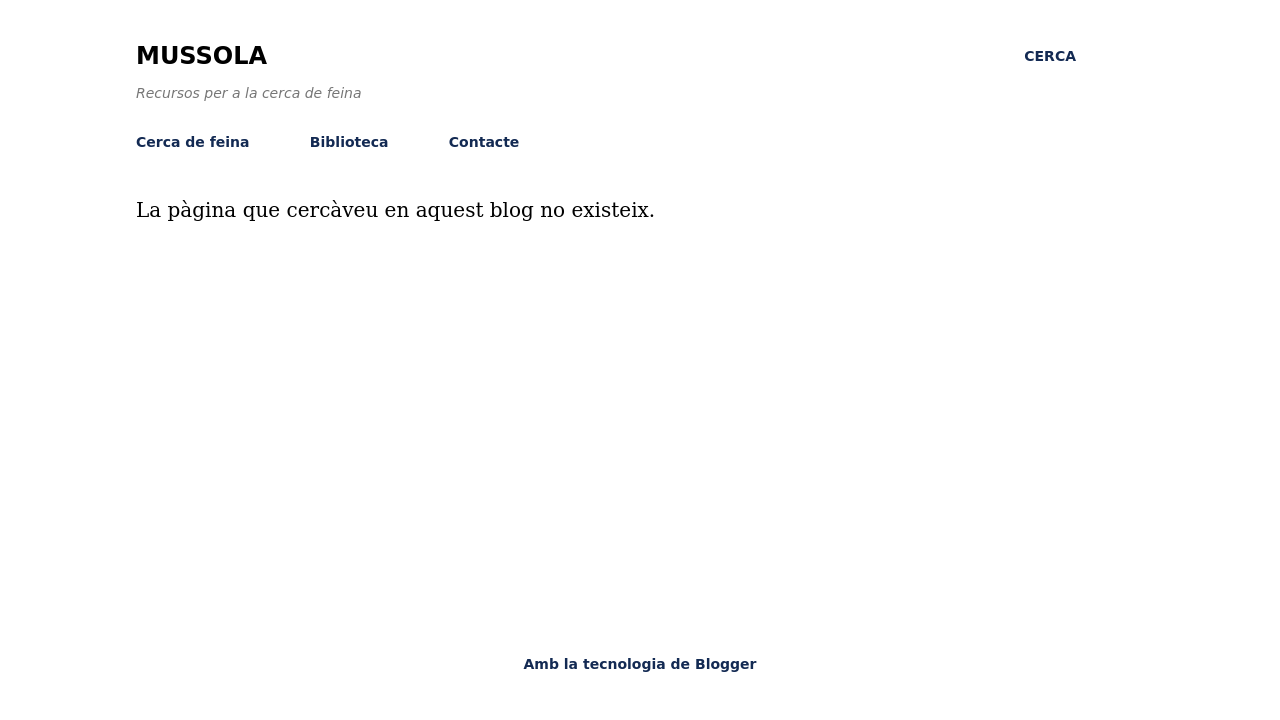Could you guide me through the process of developing this website with HTML? Certainly! To develop a website like the one shown in the image, which predominantly features textual content and simple navigation links, you'll start by setting up a basic HTML structure. You can begin with a <!DOCTYPE html> declaration, followed by creating the root HTML element. Inside, you'll typically have a <head> section for meta tags, CSS links, and a <body> where all visible content goes. In the body, you might use <header>, <nav>, <main>, and <footer> to structure the webpage semantically. For instance, your main content like text 'La pàgina que cercàveu en aquest blog no existeix.' would be placed within a <main> tag. Link various pages using <a> tags in the <nav> section for navigation. Finally, use CSS for styling to achieve the clean and minimal look as seen in the image. 